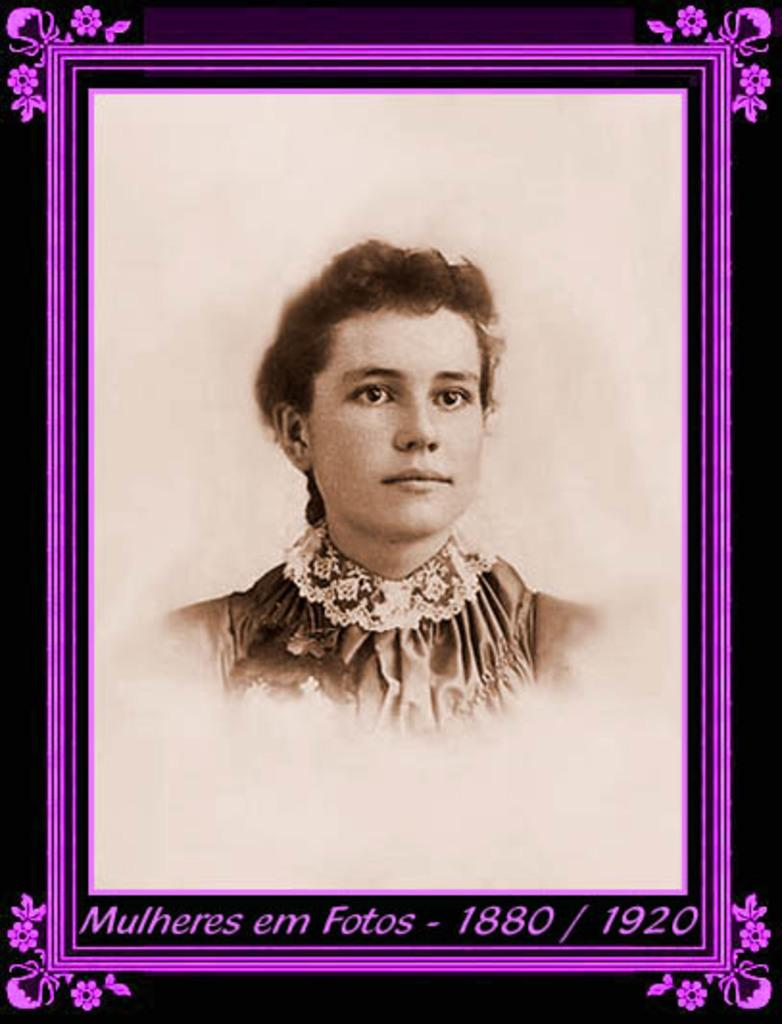What object is present in the image that typically holds a picture? There is a photo frame in the image. What can be seen inside the photo frame? The photo frame contains a picture of a person. What color is the background of the image? The background of the image is black. What type of rod can be seen in the picture? There is no rod present in the image; it features a photo frame with a picture of a person against a black background. 